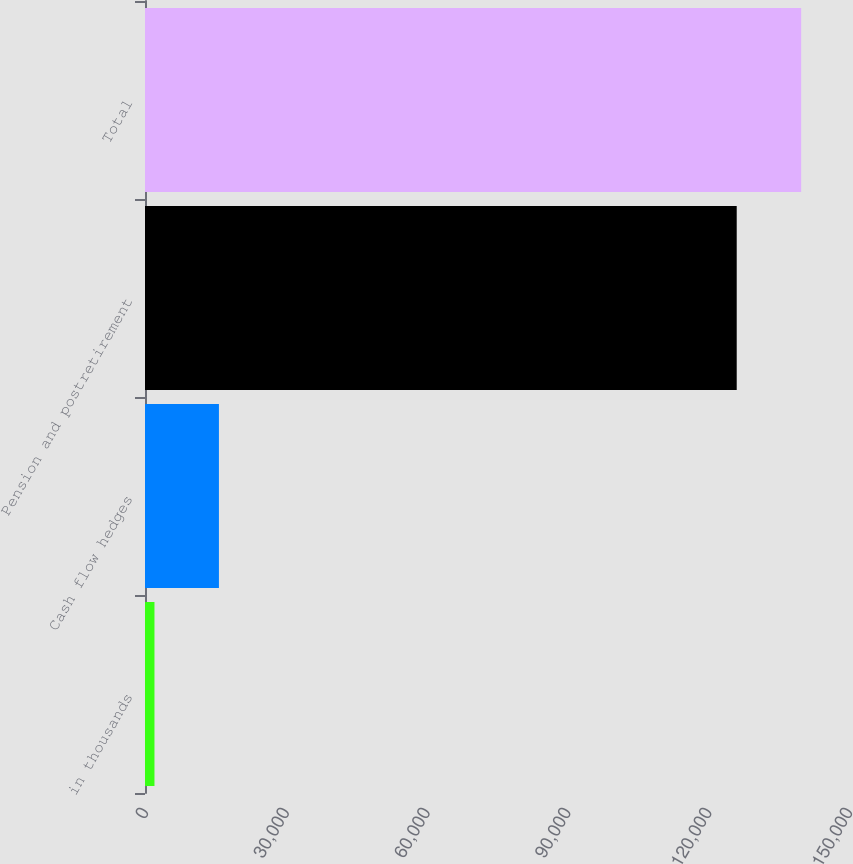<chart> <loc_0><loc_0><loc_500><loc_500><bar_chart><fcel>in thousands<fcel>Cash flow hedges<fcel>Pension and postretirement<fcel>Total<nl><fcel>2016<fcel>15752<fcel>126076<fcel>139812<nl></chart> 